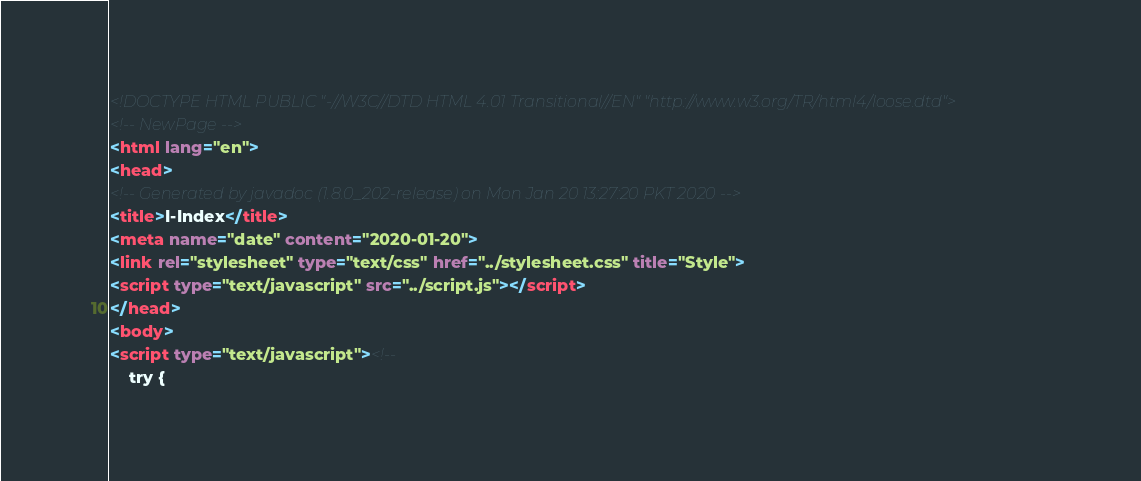<code> <loc_0><loc_0><loc_500><loc_500><_HTML_><!DOCTYPE HTML PUBLIC "-//W3C//DTD HTML 4.01 Transitional//EN" "http://www.w3.org/TR/html4/loose.dtd">
<!-- NewPage -->
<html lang="en">
<head>
<!-- Generated by javadoc (1.8.0_202-release) on Mon Jan 20 13:27:20 PKT 2020 -->
<title>I-Index</title>
<meta name="date" content="2020-01-20">
<link rel="stylesheet" type="text/css" href="../stylesheet.css" title="Style">
<script type="text/javascript" src="../script.js"></script>
</head>
<body>
<script type="text/javascript"><!--
    try {</code> 